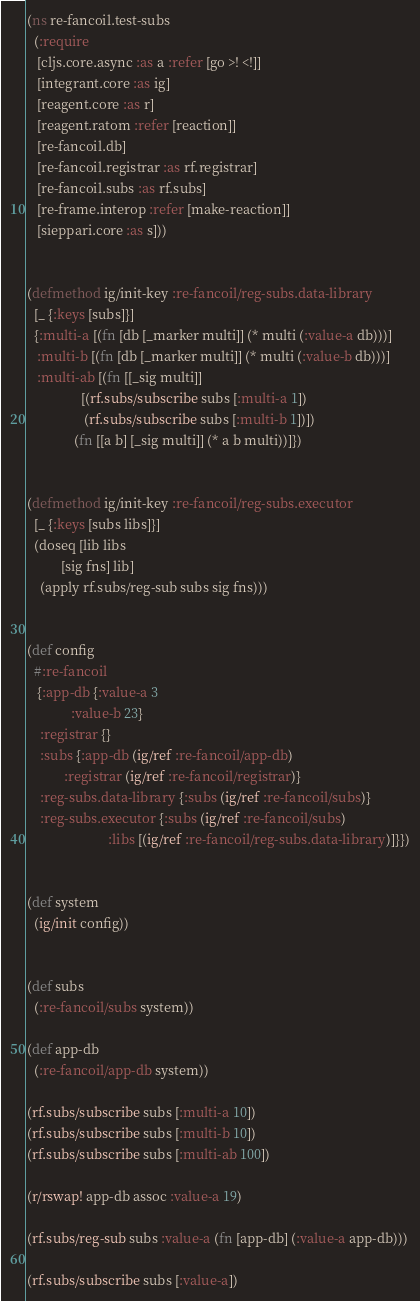<code> <loc_0><loc_0><loc_500><loc_500><_Clojure_>(ns re-fancoil.test-subs
  (:require
   [cljs.core.async :as a :refer [go >! <!]]
   [integrant.core :as ig]
   [reagent.core :as r]
   [reagent.ratom :refer [reaction]]
   [re-fancoil.db]
   [re-fancoil.registrar :as rf.registrar]
   [re-fancoil.subs :as rf.subs]
   [re-frame.interop :refer [make-reaction]]
   [sieppari.core :as s]))


(defmethod ig/init-key :re-fancoil/reg-subs.data-library
  [_ {:keys [subs]}]
  {:multi-a [(fn [db [_marker multi]] (* multi (:value-a db)))]
   :multi-b [(fn [db [_marker multi]] (* multi (:value-b db)))]
   :multi-ab [(fn [[_sig multi]]
                [(rf.subs/subscribe subs [:multi-a 1])
                 (rf.subs/subscribe subs [:multi-b 1])])
              (fn [[a b] [_sig multi]] (* a b multi))]})


(defmethod ig/init-key :re-fancoil/reg-subs.executor
  [_ {:keys [subs libs]}]
  (doseq [lib libs
          [sig fns] lib]
    (apply rf.subs/reg-sub subs sig fns)))


(def config
  #:re-fancoil
   {:app-db {:value-a 3
             :value-b 23}
    :registrar {}
    :subs {:app-db (ig/ref :re-fancoil/app-db)
           :registrar (ig/ref :re-fancoil/registrar)}
    :reg-subs.data-library {:subs (ig/ref :re-fancoil/subs)}
    :reg-subs.executor {:subs (ig/ref :re-fancoil/subs)
                        :libs [(ig/ref :re-fancoil/reg-subs.data-library)]}})


(def system
  (ig/init config))


(def subs
  (:re-fancoil/subs system))

(def app-db 
  (:re-fancoil/app-db system))

(rf.subs/subscribe subs [:multi-a 10])
(rf.subs/subscribe subs [:multi-b 10])
(rf.subs/subscribe subs [:multi-ab 100])

(r/rswap! app-db assoc :value-a 19)

(rf.subs/reg-sub subs :value-a (fn [app-db] (:value-a app-db)))

(rf.subs/subscribe subs [:value-a])</code> 